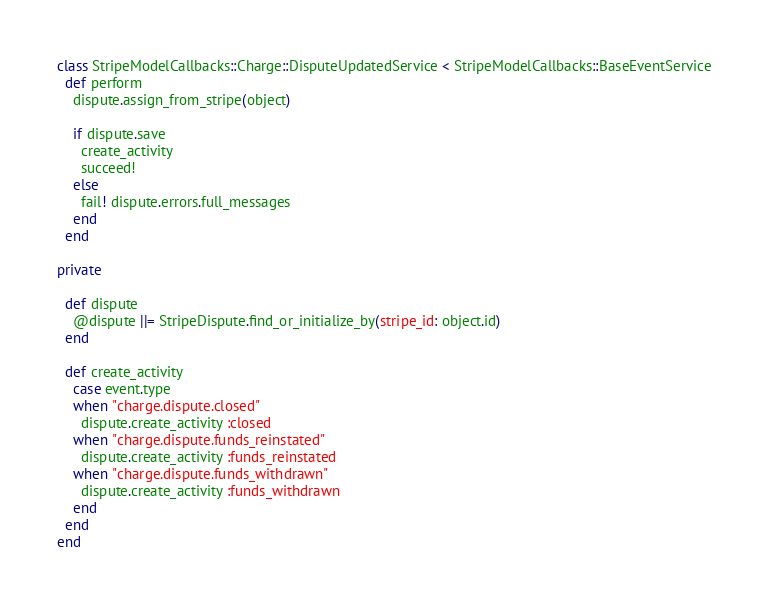Convert code to text. <code><loc_0><loc_0><loc_500><loc_500><_Ruby_>class StripeModelCallbacks::Charge::DisputeUpdatedService < StripeModelCallbacks::BaseEventService
  def perform
    dispute.assign_from_stripe(object)

    if dispute.save
      create_activity
      succeed!
    else
      fail! dispute.errors.full_messages
    end
  end

private

  def dispute
    @dispute ||= StripeDispute.find_or_initialize_by(stripe_id: object.id)
  end

  def create_activity
    case event.type
    when "charge.dispute.closed"
      dispute.create_activity :closed
    when "charge.dispute.funds_reinstated"
      dispute.create_activity :funds_reinstated
    when "charge.dispute.funds_withdrawn"
      dispute.create_activity :funds_withdrawn
    end
  end
end
</code> 